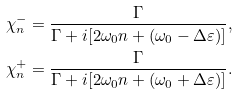Convert formula to latex. <formula><loc_0><loc_0><loc_500><loc_500>\chi _ { n } ^ { - } & = \frac { \Gamma } { \Gamma + i [ 2 \omega _ { 0 } n + ( \omega _ { 0 } - \Delta \varepsilon ) ] } , \\ \chi _ { n } ^ { + } & = \frac { \Gamma } { \Gamma + i [ 2 \omega _ { 0 } n + ( \omega _ { 0 } + \Delta \varepsilon ) ] } .</formula> 